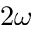<formula> <loc_0><loc_0><loc_500><loc_500>2 \omega</formula> 